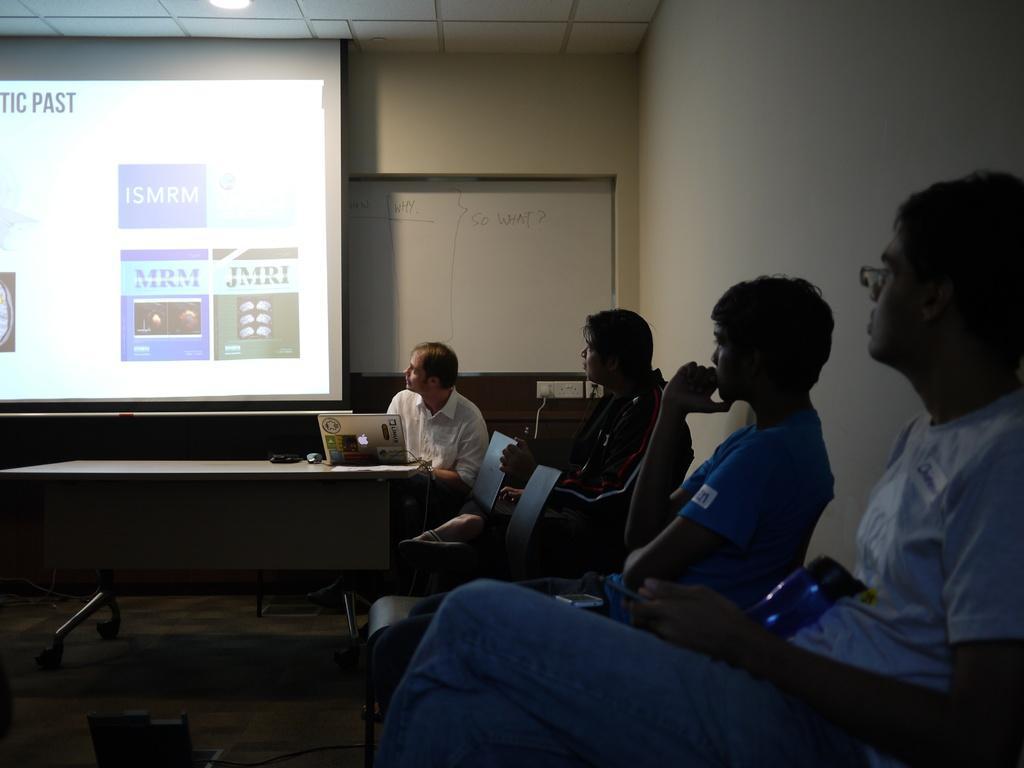How would you summarize this image in a sentence or two? In this image, we can a few people sitting. We can also see a table with some devices on it. We can see a projector screen and a board. We can see the wall, roof and the ground. 